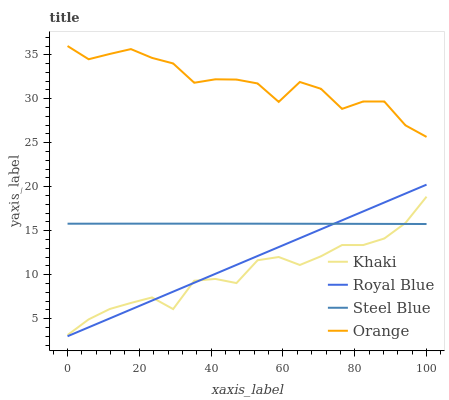Does Khaki have the minimum area under the curve?
Answer yes or no. Yes. Does Orange have the maximum area under the curve?
Answer yes or no. Yes. Does Royal Blue have the minimum area under the curve?
Answer yes or no. No. Does Royal Blue have the maximum area under the curve?
Answer yes or no. No. Is Royal Blue the smoothest?
Answer yes or no. Yes. Is Orange the roughest?
Answer yes or no. Yes. Is Khaki the smoothest?
Answer yes or no. No. Is Khaki the roughest?
Answer yes or no. No. Does Royal Blue have the lowest value?
Answer yes or no. Yes. Does Khaki have the lowest value?
Answer yes or no. No. Does Orange have the highest value?
Answer yes or no. Yes. Does Royal Blue have the highest value?
Answer yes or no. No. Is Khaki less than Orange?
Answer yes or no. Yes. Is Orange greater than Royal Blue?
Answer yes or no. Yes. Does Khaki intersect Steel Blue?
Answer yes or no. Yes. Is Khaki less than Steel Blue?
Answer yes or no. No. Is Khaki greater than Steel Blue?
Answer yes or no. No. Does Khaki intersect Orange?
Answer yes or no. No. 